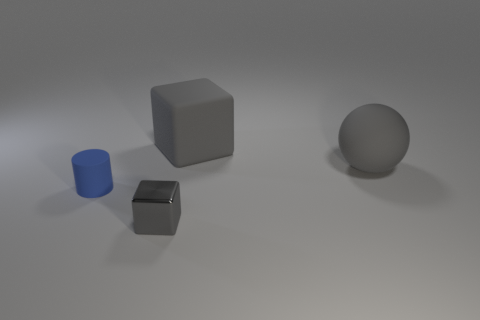Add 2 tiny green spheres. How many objects exist? 6 Subtract 1 cylinders. How many cylinders are left? 0 Subtract 0 yellow cylinders. How many objects are left? 4 Subtract all yellow blocks. Subtract all red cylinders. How many blocks are left? 2 Subtract all large gray matte spheres. Subtract all large gray things. How many objects are left? 1 Add 1 blue things. How many blue things are left? 2 Add 2 large matte cubes. How many large matte cubes exist? 3 